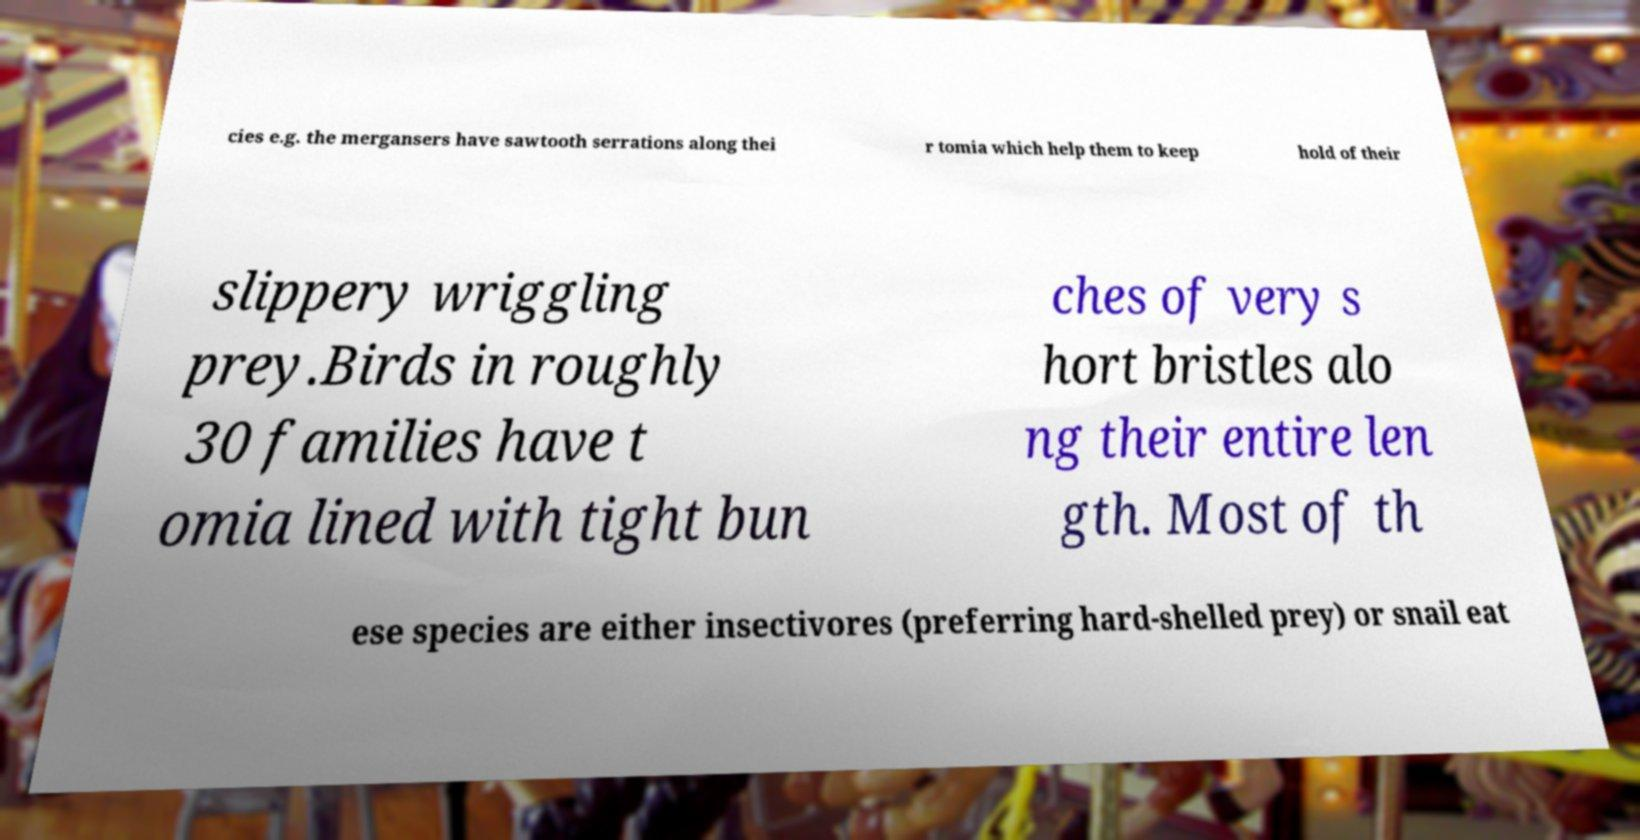For documentation purposes, I need the text within this image transcribed. Could you provide that? cies e.g. the mergansers have sawtooth serrations along thei r tomia which help them to keep hold of their slippery wriggling prey.Birds in roughly 30 families have t omia lined with tight bun ches of very s hort bristles alo ng their entire len gth. Most of th ese species are either insectivores (preferring hard-shelled prey) or snail eat 